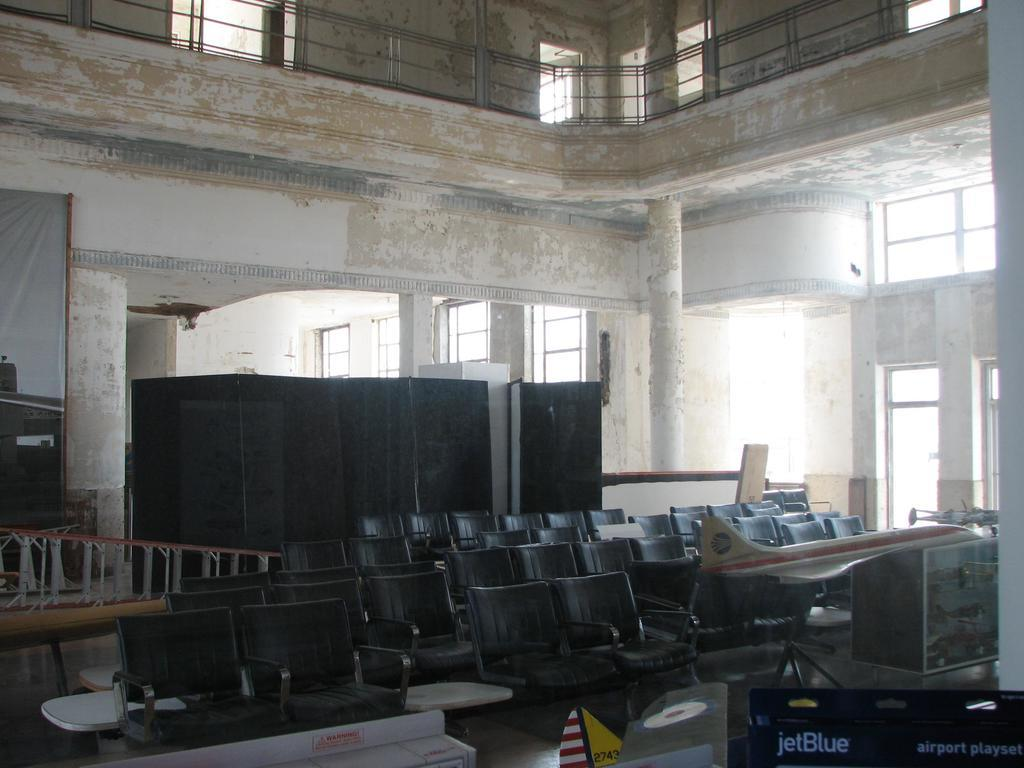What type of location is depicted in the image? The image is an inside view of a building. What architectural feature can be seen in the building? There are windows in the building. What type of security feature is present in the building? There are iron grills in the building. What type of furniture is present in the building? There are chairs and tables in the building. What unusual object can be seen in the building? There is a demo airplane in the building. What type of fold can be seen in the image? There is no fold present in the image. The image depicts an inside view of a building with windows, iron grills, chairs, tables, and a demo airplane. 